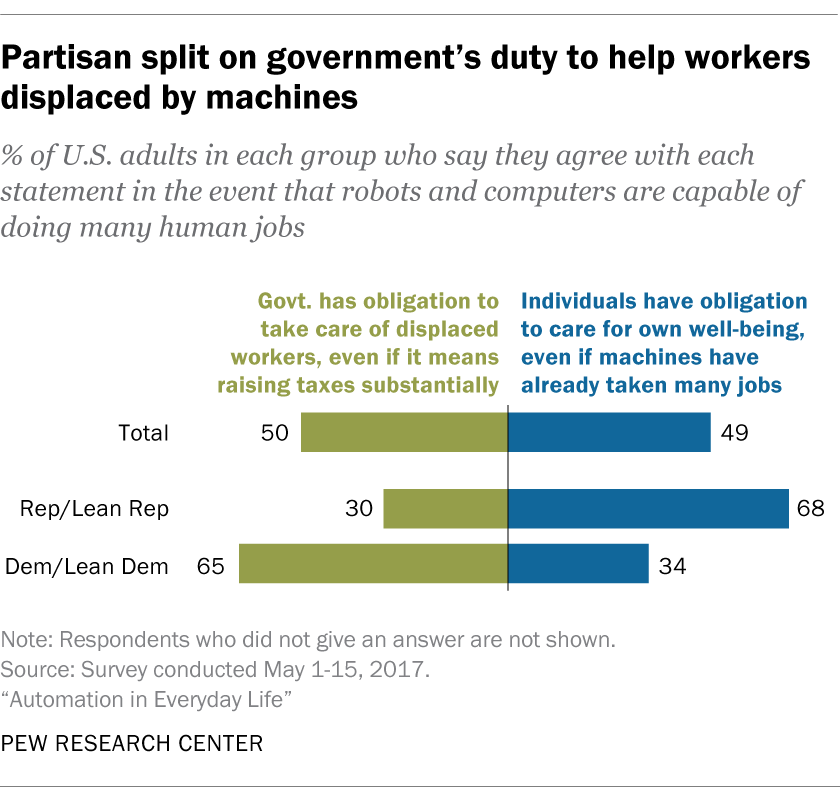Draw attention to some important aspects in this diagram. 50% of the respondents believe that the government has an obligation to take care of displaced workers, even if it means raising taxes substantially. The difference between Democratic and Lean Democratic values is that the government has an obligation to provide for displaced workers, even if it requires substantial tax increases, while individuals are responsible for taking care of their own well-being, even if machines have taken many jobs. 